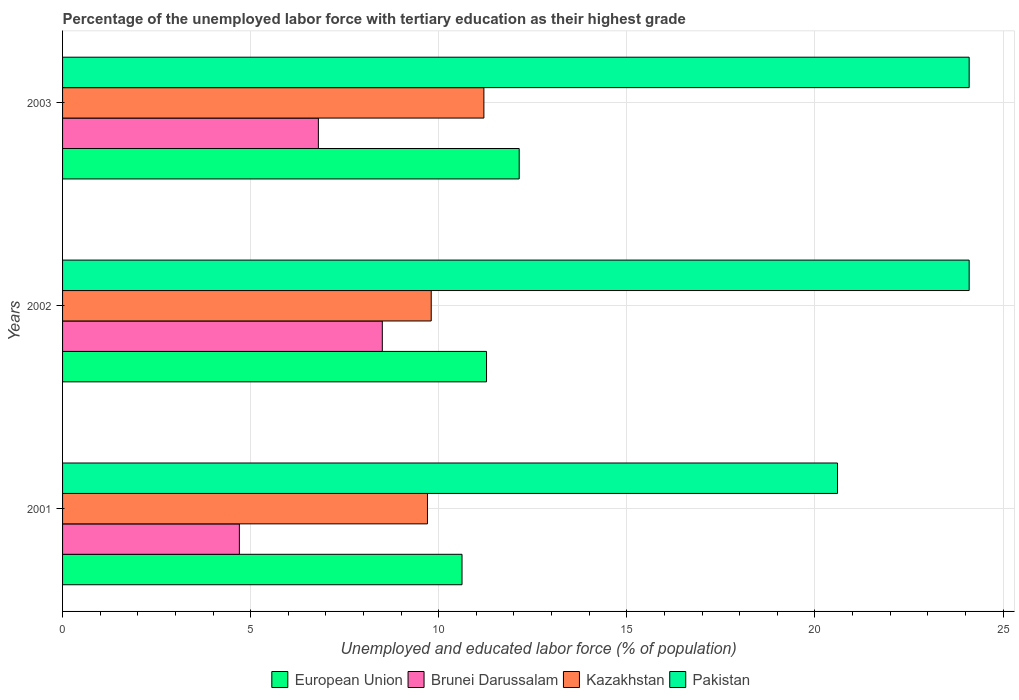How many different coloured bars are there?
Your answer should be very brief. 4. How many groups of bars are there?
Make the answer very short. 3. Are the number of bars on each tick of the Y-axis equal?
Offer a terse response. Yes. In how many cases, is the number of bars for a given year not equal to the number of legend labels?
Give a very brief answer. 0. What is the percentage of the unemployed labor force with tertiary education in Kazakhstan in 2003?
Ensure brevity in your answer.  11.2. Across all years, what is the maximum percentage of the unemployed labor force with tertiary education in Kazakhstan?
Make the answer very short. 11.2. Across all years, what is the minimum percentage of the unemployed labor force with tertiary education in Pakistan?
Provide a succinct answer. 20.6. In which year was the percentage of the unemployed labor force with tertiary education in Kazakhstan maximum?
Offer a terse response. 2003. In which year was the percentage of the unemployed labor force with tertiary education in European Union minimum?
Provide a succinct answer. 2001. What is the total percentage of the unemployed labor force with tertiary education in Pakistan in the graph?
Provide a succinct answer. 68.8. What is the difference between the percentage of the unemployed labor force with tertiary education in Brunei Darussalam in 2002 and that in 2003?
Your response must be concise. 1.7. What is the difference between the percentage of the unemployed labor force with tertiary education in Kazakhstan in 2001 and the percentage of the unemployed labor force with tertiary education in European Union in 2002?
Keep it short and to the point. -1.57. What is the average percentage of the unemployed labor force with tertiary education in Pakistan per year?
Ensure brevity in your answer.  22.93. In the year 2003, what is the difference between the percentage of the unemployed labor force with tertiary education in Brunei Darussalam and percentage of the unemployed labor force with tertiary education in Kazakhstan?
Provide a short and direct response. -4.4. In how many years, is the percentage of the unemployed labor force with tertiary education in Brunei Darussalam greater than 16 %?
Ensure brevity in your answer.  0. What is the ratio of the percentage of the unemployed labor force with tertiary education in Brunei Darussalam in 2001 to that in 2003?
Ensure brevity in your answer.  0.69. Is the percentage of the unemployed labor force with tertiary education in European Union in 2001 less than that in 2002?
Your response must be concise. Yes. Is the difference between the percentage of the unemployed labor force with tertiary education in Brunei Darussalam in 2002 and 2003 greater than the difference between the percentage of the unemployed labor force with tertiary education in Kazakhstan in 2002 and 2003?
Your answer should be compact. Yes. What is the difference between the highest and the second highest percentage of the unemployed labor force with tertiary education in Brunei Darussalam?
Make the answer very short. 1.7. What is the difference between the highest and the lowest percentage of the unemployed labor force with tertiary education in Kazakhstan?
Make the answer very short. 1.5. Is it the case that in every year, the sum of the percentage of the unemployed labor force with tertiary education in Brunei Darussalam and percentage of the unemployed labor force with tertiary education in Kazakhstan is greater than the sum of percentage of the unemployed labor force with tertiary education in Pakistan and percentage of the unemployed labor force with tertiary education in European Union?
Offer a very short reply. No. What does the 2nd bar from the top in 2001 represents?
Your answer should be compact. Kazakhstan. What does the 2nd bar from the bottom in 2001 represents?
Ensure brevity in your answer.  Brunei Darussalam. How many bars are there?
Make the answer very short. 12. How many years are there in the graph?
Make the answer very short. 3. Are the values on the major ticks of X-axis written in scientific E-notation?
Provide a succinct answer. No. Does the graph contain any zero values?
Your answer should be very brief. No. How are the legend labels stacked?
Offer a terse response. Horizontal. What is the title of the graph?
Offer a terse response. Percentage of the unemployed labor force with tertiary education as their highest grade. What is the label or title of the X-axis?
Offer a very short reply. Unemployed and educated labor force (% of population). What is the label or title of the Y-axis?
Your answer should be compact. Years. What is the Unemployed and educated labor force (% of population) of European Union in 2001?
Offer a terse response. 10.62. What is the Unemployed and educated labor force (% of population) in Brunei Darussalam in 2001?
Offer a terse response. 4.7. What is the Unemployed and educated labor force (% of population) in Kazakhstan in 2001?
Provide a short and direct response. 9.7. What is the Unemployed and educated labor force (% of population) in Pakistan in 2001?
Offer a very short reply. 20.6. What is the Unemployed and educated labor force (% of population) of European Union in 2002?
Provide a succinct answer. 11.27. What is the Unemployed and educated labor force (% of population) in Kazakhstan in 2002?
Give a very brief answer. 9.8. What is the Unemployed and educated labor force (% of population) of Pakistan in 2002?
Ensure brevity in your answer.  24.1. What is the Unemployed and educated labor force (% of population) in European Union in 2003?
Your answer should be very brief. 12.14. What is the Unemployed and educated labor force (% of population) of Brunei Darussalam in 2003?
Give a very brief answer. 6.8. What is the Unemployed and educated labor force (% of population) of Kazakhstan in 2003?
Your response must be concise. 11.2. What is the Unemployed and educated labor force (% of population) in Pakistan in 2003?
Provide a short and direct response. 24.1. Across all years, what is the maximum Unemployed and educated labor force (% of population) in European Union?
Your answer should be compact. 12.14. Across all years, what is the maximum Unemployed and educated labor force (% of population) in Brunei Darussalam?
Provide a short and direct response. 8.5. Across all years, what is the maximum Unemployed and educated labor force (% of population) of Kazakhstan?
Your answer should be very brief. 11.2. Across all years, what is the maximum Unemployed and educated labor force (% of population) in Pakistan?
Ensure brevity in your answer.  24.1. Across all years, what is the minimum Unemployed and educated labor force (% of population) in European Union?
Keep it short and to the point. 10.62. Across all years, what is the minimum Unemployed and educated labor force (% of population) in Brunei Darussalam?
Your response must be concise. 4.7. Across all years, what is the minimum Unemployed and educated labor force (% of population) of Kazakhstan?
Offer a very short reply. 9.7. Across all years, what is the minimum Unemployed and educated labor force (% of population) of Pakistan?
Provide a short and direct response. 20.6. What is the total Unemployed and educated labor force (% of population) in European Union in the graph?
Your answer should be very brief. 34.03. What is the total Unemployed and educated labor force (% of population) in Brunei Darussalam in the graph?
Make the answer very short. 20. What is the total Unemployed and educated labor force (% of population) in Kazakhstan in the graph?
Keep it short and to the point. 30.7. What is the total Unemployed and educated labor force (% of population) of Pakistan in the graph?
Offer a very short reply. 68.8. What is the difference between the Unemployed and educated labor force (% of population) in European Union in 2001 and that in 2002?
Keep it short and to the point. -0.65. What is the difference between the Unemployed and educated labor force (% of population) of European Union in 2001 and that in 2003?
Provide a succinct answer. -1.52. What is the difference between the Unemployed and educated labor force (% of population) in European Union in 2002 and that in 2003?
Your response must be concise. -0.87. What is the difference between the Unemployed and educated labor force (% of population) in Kazakhstan in 2002 and that in 2003?
Offer a terse response. -1.4. What is the difference between the Unemployed and educated labor force (% of population) in European Union in 2001 and the Unemployed and educated labor force (% of population) in Brunei Darussalam in 2002?
Provide a short and direct response. 2.12. What is the difference between the Unemployed and educated labor force (% of population) of European Union in 2001 and the Unemployed and educated labor force (% of population) of Kazakhstan in 2002?
Your answer should be compact. 0.82. What is the difference between the Unemployed and educated labor force (% of population) in European Union in 2001 and the Unemployed and educated labor force (% of population) in Pakistan in 2002?
Offer a very short reply. -13.48. What is the difference between the Unemployed and educated labor force (% of population) of Brunei Darussalam in 2001 and the Unemployed and educated labor force (% of population) of Kazakhstan in 2002?
Ensure brevity in your answer.  -5.1. What is the difference between the Unemployed and educated labor force (% of population) of Brunei Darussalam in 2001 and the Unemployed and educated labor force (% of population) of Pakistan in 2002?
Ensure brevity in your answer.  -19.4. What is the difference between the Unemployed and educated labor force (% of population) of Kazakhstan in 2001 and the Unemployed and educated labor force (% of population) of Pakistan in 2002?
Your answer should be compact. -14.4. What is the difference between the Unemployed and educated labor force (% of population) in European Union in 2001 and the Unemployed and educated labor force (% of population) in Brunei Darussalam in 2003?
Provide a short and direct response. 3.82. What is the difference between the Unemployed and educated labor force (% of population) in European Union in 2001 and the Unemployed and educated labor force (% of population) in Kazakhstan in 2003?
Your response must be concise. -0.58. What is the difference between the Unemployed and educated labor force (% of population) in European Union in 2001 and the Unemployed and educated labor force (% of population) in Pakistan in 2003?
Ensure brevity in your answer.  -13.48. What is the difference between the Unemployed and educated labor force (% of population) in Brunei Darussalam in 2001 and the Unemployed and educated labor force (% of population) in Kazakhstan in 2003?
Give a very brief answer. -6.5. What is the difference between the Unemployed and educated labor force (% of population) in Brunei Darussalam in 2001 and the Unemployed and educated labor force (% of population) in Pakistan in 2003?
Offer a terse response. -19.4. What is the difference between the Unemployed and educated labor force (% of population) in Kazakhstan in 2001 and the Unemployed and educated labor force (% of population) in Pakistan in 2003?
Ensure brevity in your answer.  -14.4. What is the difference between the Unemployed and educated labor force (% of population) in European Union in 2002 and the Unemployed and educated labor force (% of population) in Brunei Darussalam in 2003?
Give a very brief answer. 4.47. What is the difference between the Unemployed and educated labor force (% of population) in European Union in 2002 and the Unemployed and educated labor force (% of population) in Kazakhstan in 2003?
Your response must be concise. 0.07. What is the difference between the Unemployed and educated labor force (% of population) in European Union in 2002 and the Unemployed and educated labor force (% of population) in Pakistan in 2003?
Your answer should be very brief. -12.83. What is the difference between the Unemployed and educated labor force (% of population) of Brunei Darussalam in 2002 and the Unemployed and educated labor force (% of population) of Pakistan in 2003?
Offer a very short reply. -15.6. What is the difference between the Unemployed and educated labor force (% of population) in Kazakhstan in 2002 and the Unemployed and educated labor force (% of population) in Pakistan in 2003?
Give a very brief answer. -14.3. What is the average Unemployed and educated labor force (% of population) in European Union per year?
Your answer should be compact. 11.34. What is the average Unemployed and educated labor force (% of population) in Kazakhstan per year?
Your answer should be compact. 10.23. What is the average Unemployed and educated labor force (% of population) in Pakistan per year?
Provide a short and direct response. 22.93. In the year 2001, what is the difference between the Unemployed and educated labor force (% of population) of European Union and Unemployed and educated labor force (% of population) of Brunei Darussalam?
Your answer should be compact. 5.92. In the year 2001, what is the difference between the Unemployed and educated labor force (% of population) of European Union and Unemployed and educated labor force (% of population) of Kazakhstan?
Your answer should be very brief. 0.92. In the year 2001, what is the difference between the Unemployed and educated labor force (% of population) of European Union and Unemployed and educated labor force (% of population) of Pakistan?
Your response must be concise. -9.98. In the year 2001, what is the difference between the Unemployed and educated labor force (% of population) in Brunei Darussalam and Unemployed and educated labor force (% of population) in Pakistan?
Provide a short and direct response. -15.9. In the year 2002, what is the difference between the Unemployed and educated labor force (% of population) of European Union and Unemployed and educated labor force (% of population) of Brunei Darussalam?
Keep it short and to the point. 2.77. In the year 2002, what is the difference between the Unemployed and educated labor force (% of population) of European Union and Unemployed and educated labor force (% of population) of Kazakhstan?
Your answer should be very brief. 1.47. In the year 2002, what is the difference between the Unemployed and educated labor force (% of population) in European Union and Unemployed and educated labor force (% of population) in Pakistan?
Keep it short and to the point. -12.83. In the year 2002, what is the difference between the Unemployed and educated labor force (% of population) in Brunei Darussalam and Unemployed and educated labor force (% of population) in Pakistan?
Offer a terse response. -15.6. In the year 2002, what is the difference between the Unemployed and educated labor force (% of population) of Kazakhstan and Unemployed and educated labor force (% of population) of Pakistan?
Offer a terse response. -14.3. In the year 2003, what is the difference between the Unemployed and educated labor force (% of population) of European Union and Unemployed and educated labor force (% of population) of Brunei Darussalam?
Provide a short and direct response. 5.34. In the year 2003, what is the difference between the Unemployed and educated labor force (% of population) of European Union and Unemployed and educated labor force (% of population) of Kazakhstan?
Your response must be concise. 0.94. In the year 2003, what is the difference between the Unemployed and educated labor force (% of population) of European Union and Unemployed and educated labor force (% of population) of Pakistan?
Keep it short and to the point. -11.96. In the year 2003, what is the difference between the Unemployed and educated labor force (% of population) of Brunei Darussalam and Unemployed and educated labor force (% of population) of Kazakhstan?
Provide a short and direct response. -4.4. In the year 2003, what is the difference between the Unemployed and educated labor force (% of population) in Brunei Darussalam and Unemployed and educated labor force (% of population) in Pakistan?
Give a very brief answer. -17.3. In the year 2003, what is the difference between the Unemployed and educated labor force (% of population) of Kazakhstan and Unemployed and educated labor force (% of population) of Pakistan?
Make the answer very short. -12.9. What is the ratio of the Unemployed and educated labor force (% of population) of European Union in 2001 to that in 2002?
Offer a terse response. 0.94. What is the ratio of the Unemployed and educated labor force (% of population) of Brunei Darussalam in 2001 to that in 2002?
Your answer should be compact. 0.55. What is the ratio of the Unemployed and educated labor force (% of population) in Kazakhstan in 2001 to that in 2002?
Make the answer very short. 0.99. What is the ratio of the Unemployed and educated labor force (% of population) of Pakistan in 2001 to that in 2002?
Make the answer very short. 0.85. What is the ratio of the Unemployed and educated labor force (% of population) of European Union in 2001 to that in 2003?
Your answer should be very brief. 0.87. What is the ratio of the Unemployed and educated labor force (% of population) of Brunei Darussalam in 2001 to that in 2003?
Keep it short and to the point. 0.69. What is the ratio of the Unemployed and educated labor force (% of population) in Kazakhstan in 2001 to that in 2003?
Make the answer very short. 0.87. What is the ratio of the Unemployed and educated labor force (% of population) of Pakistan in 2001 to that in 2003?
Offer a terse response. 0.85. What is the ratio of the Unemployed and educated labor force (% of population) in European Union in 2002 to that in 2003?
Your answer should be very brief. 0.93. What is the ratio of the Unemployed and educated labor force (% of population) of Brunei Darussalam in 2002 to that in 2003?
Offer a very short reply. 1.25. What is the ratio of the Unemployed and educated labor force (% of population) in Kazakhstan in 2002 to that in 2003?
Provide a short and direct response. 0.88. What is the difference between the highest and the second highest Unemployed and educated labor force (% of population) of European Union?
Offer a very short reply. 0.87. What is the difference between the highest and the lowest Unemployed and educated labor force (% of population) in European Union?
Your answer should be compact. 1.52. What is the difference between the highest and the lowest Unemployed and educated labor force (% of population) of Kazakhstan?
Your response must be concise. 1.5. 